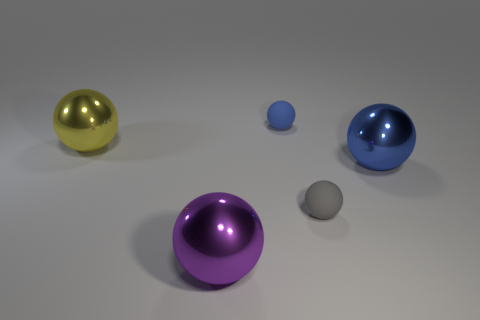What is the shape of the purple metallic thing in front of the matte sphere behind the gray rubber sphere?
Keep it short and to the point. Sphere. How many other things are there of the same material as the big purple thing?
Your answer should be very brief. 2. Are there more large purple metal things than green blocks?
Give a very brief answer. Yes. There is a metallic object that is in front of the small gray rubber sphere in front of the object that is to the left of the big purple ball; what is its size?
Ensure brevity in your answer.  Large. Does the blue rubber sphere have the same size as the blue thing that is on the right side of the gray matte thing?
Your response must be concise. No. Are there fewer small gray objects on the left side of the yellow thing than gray spheres?
Your response must be concise. Yes. Are there fewer small gray matte objects than small purple rubber cylinders?
Your answer should be very brief. No. Is the material of the large purple thing the same as the small gray ball?
Offer a very short reply. No. How many other objects are there of the same size as the blue matte object?
Keep it short and to the point. 1. What color is the large ball that is right of the tiny sphere that is behind the gray matte object?
Provide a succinct answer. Blue. 